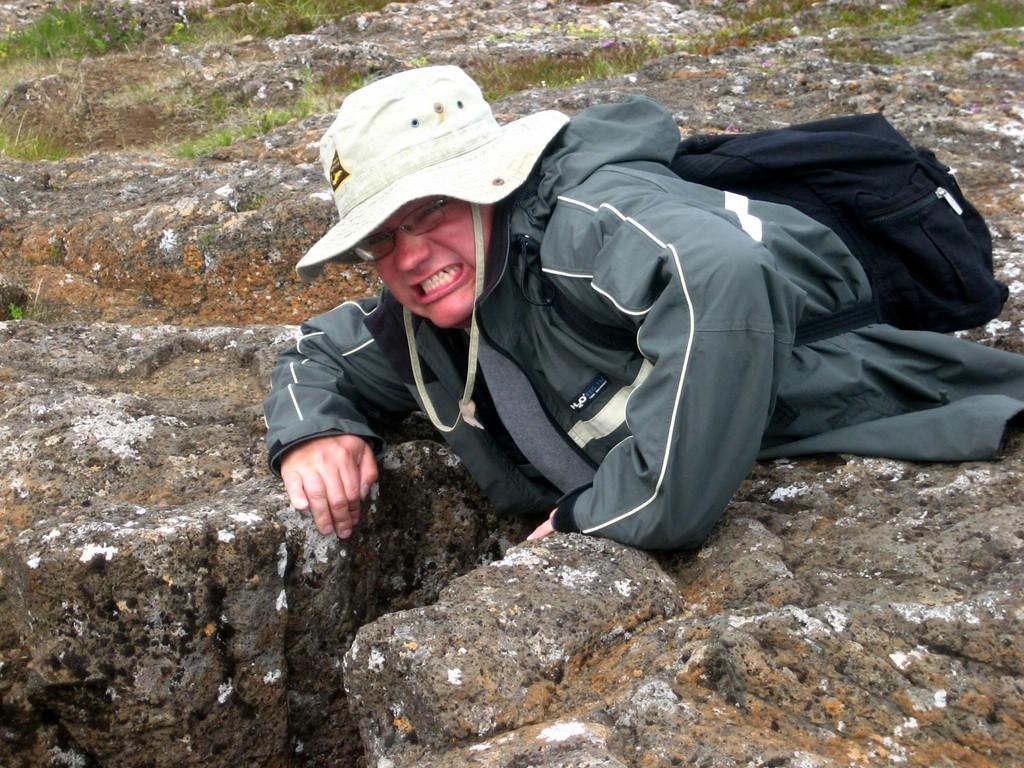Describe this image in one or two sentences. In this image there is a man in the center wearing white colour hat and there is black colour bag along with him. In the background there is grass on the ground. 